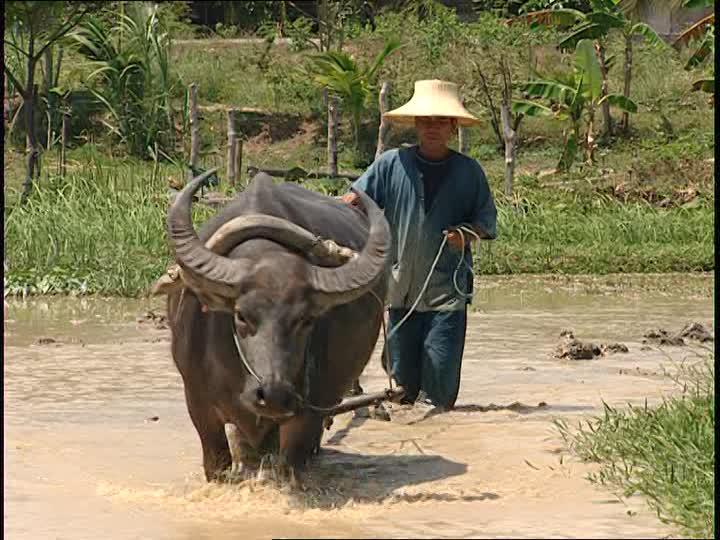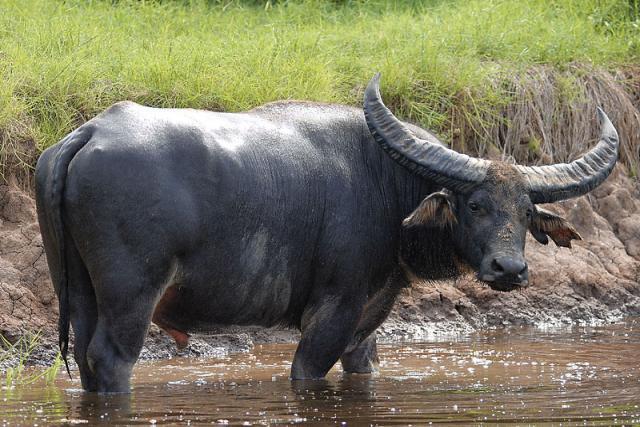The first image is the image on the left, the second image is the image on the right. For the images displayed, is the sentence "An image shows at least one forward-looking ox with a rope threaded through its nose, standing in a wet, muddy area." factually correct? Answer yes or no. Yes. The first image is the image on the left, the second image is the image on the right. Examine the images to the left and right. Is the description "The cow in the image on the right is near a watery area." accurate? Answer yes or no. Yes. 